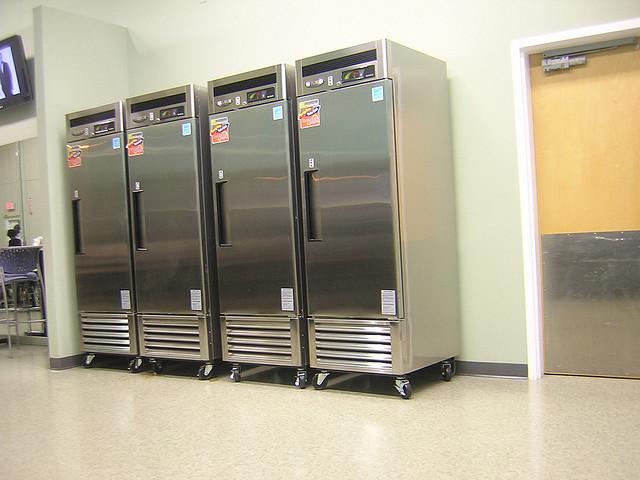How many refrigerators are depicted in this scene?
Write a very short answer. 4. Are these refrigerators in a home kitchen?
Quick response, please. No. Are the appliances silver?
Quick response, please. Yes. 